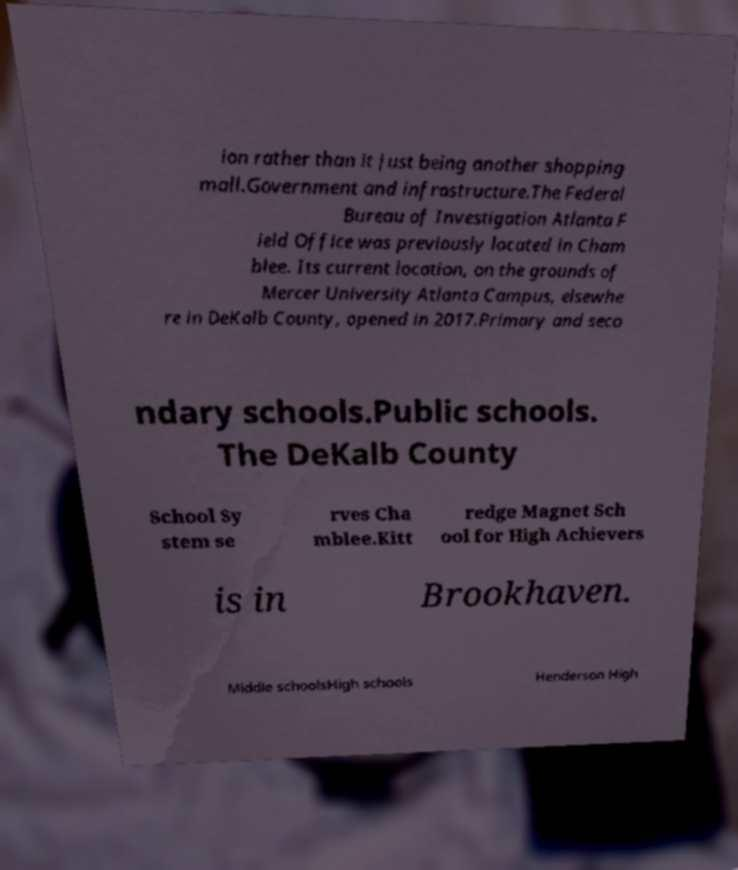For documentation purposes, I need the text within this image transcribed. Could you provide that? ion rather than it just being another shopping mall.Government and infrastructure.The Federal Bureau of Investigation Atlanta F ield Office was previously located in Cham blee. Its current location, on the grounds of Mercer University Atlanta Campus, elsewhe re in DeKalb County, opened in 2017.Primary and seco ndary schools.Public schools. The DeKalb County School Sy stem se rves Cha mblee.Kitt redge Magnet Sch ool for High Achievers is in Brookhaven. Middle schoolsHigh schools Henderson High 